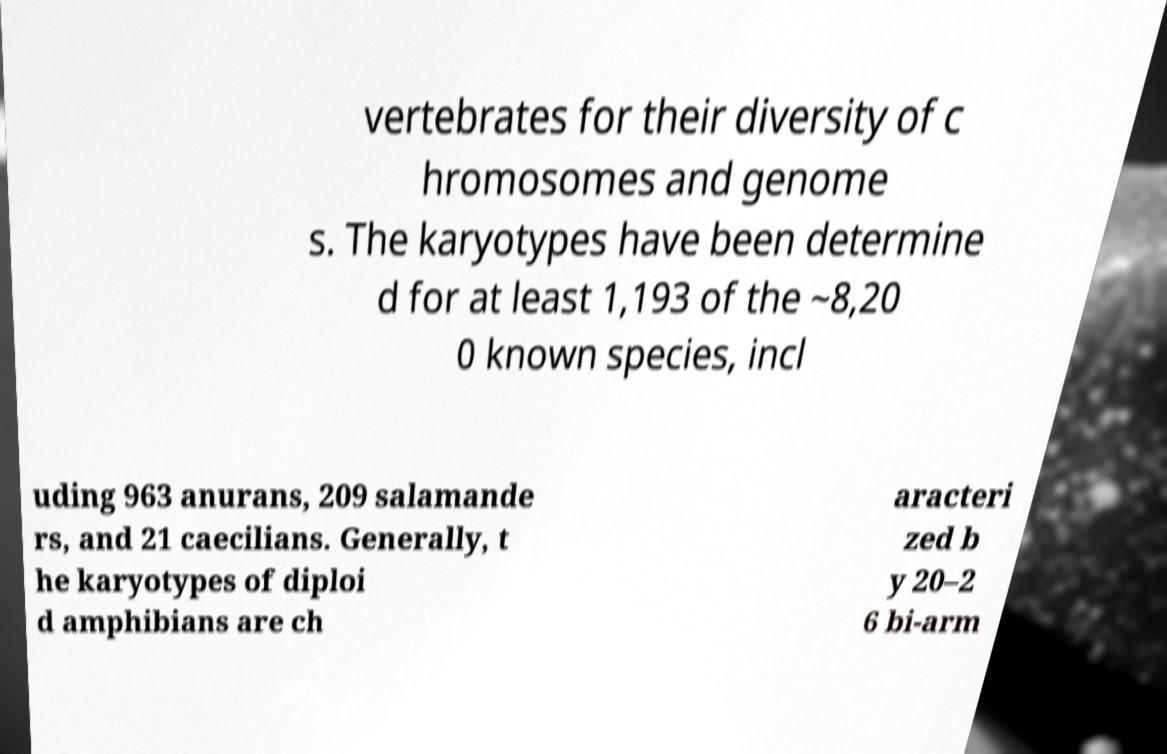There's text embedded in this image that I need extracted. Can you transcribe it verbatim? vertebrates for their diversity of c hromosomes and genome s. The karyotypes have been determine d for at least 1,193 of the ~8,20 0 known species, incl uding 963 anurans, 209 salamande rs, and 21 caecilians. Generally, t he karyotypes of diploi d amphibians are ch aracteri zed b y 20–2 6 bi-arm 